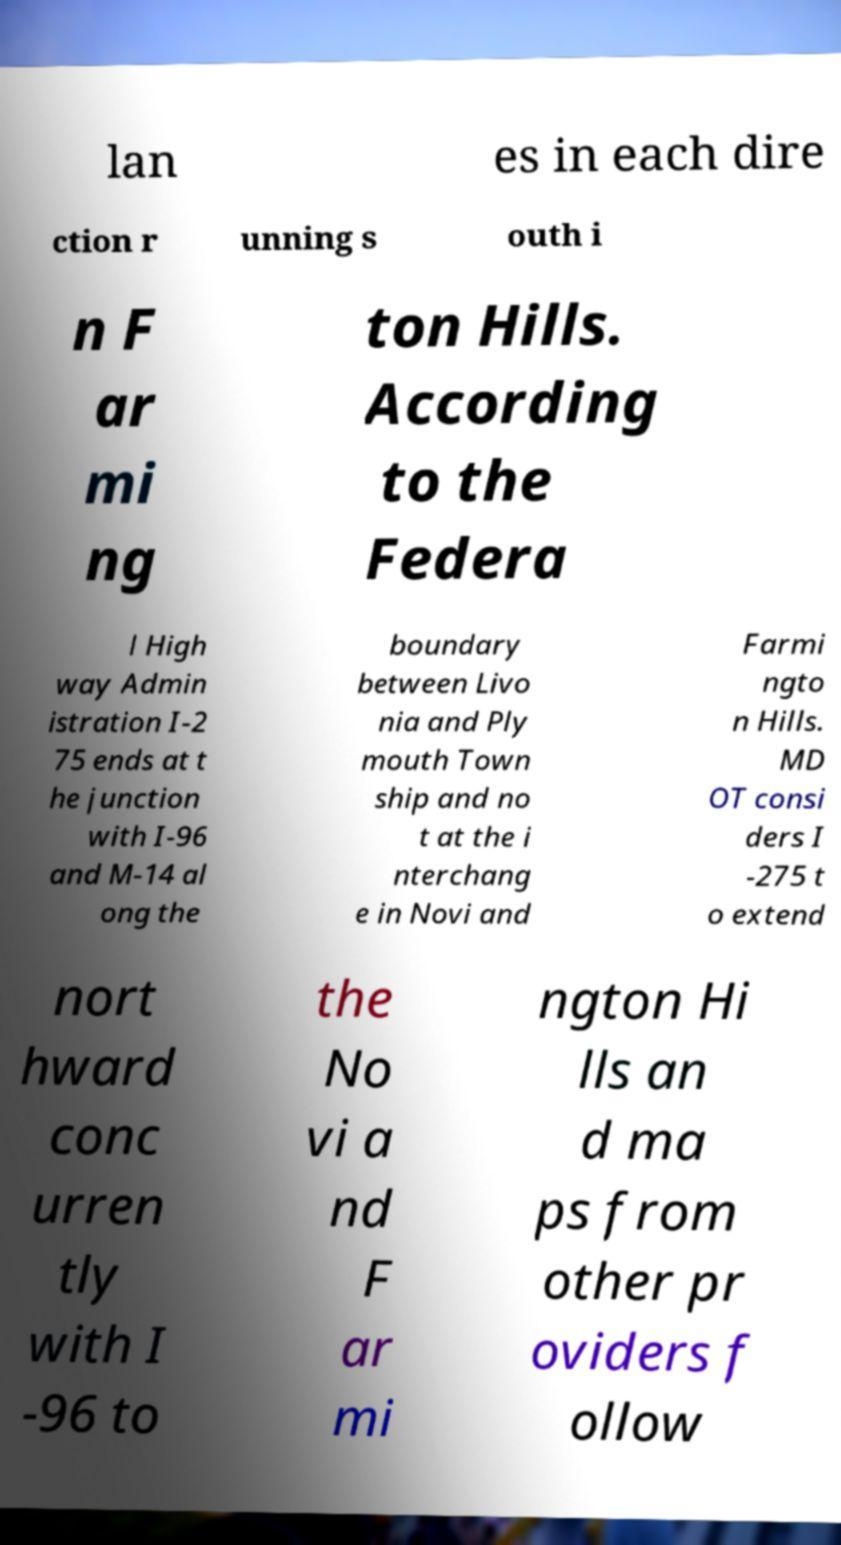I need the written content from this picture converted into text. Can you do that? lan es in each dire ction r unning s outh i n F ar mi ng ton Hills. According to the Federa l High way Admin istration I-2 75 ends at t he junction with I-96 and M-14 al ong the boundary between Livo nia and Ply mouth Town ship and no t at the i nterchang e in Novi and Farmi ngto n Hills. MD OT consi ders I -275 t o extend nort hward conc urren tly with I -96 to the No vi a nd F ar mi ngton Hi lls an d ma ps from other pr oviders f ollow 